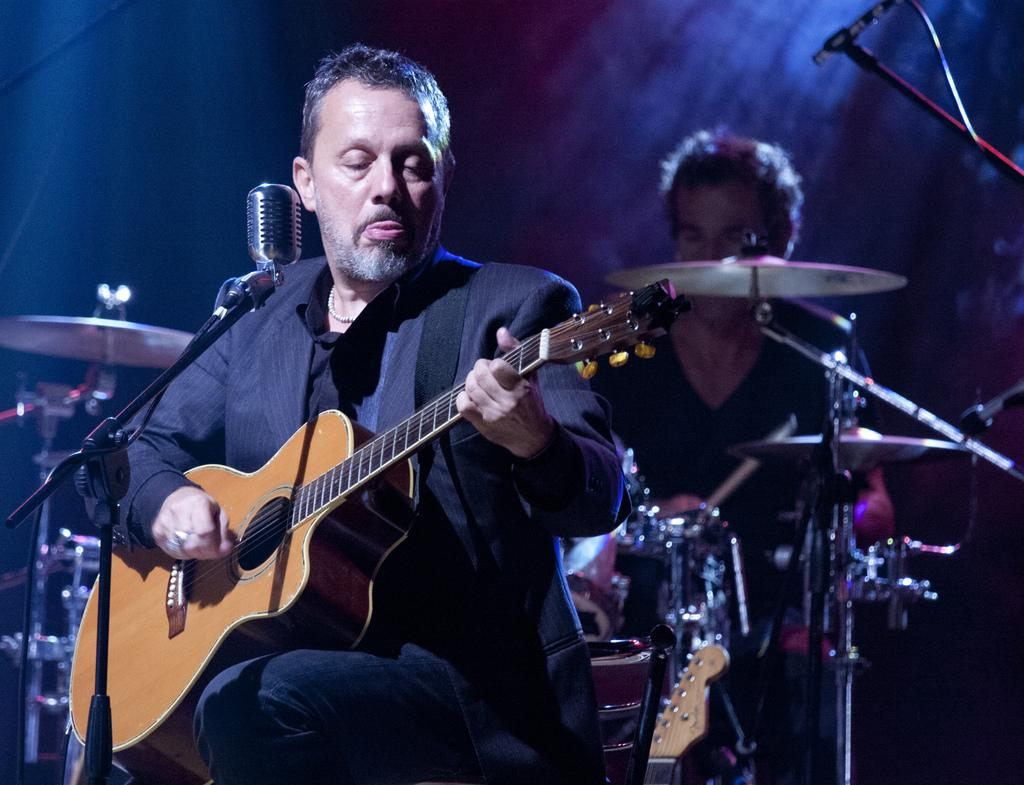What is the main activity being performed by the first man in the image? The first man is playing a guitar. What is the main activity being performed by the second man in the image? The second man is playing drums. What verse is the man playing the guitar reciting in the image? There is no indication in the image that the man playing the guitar is reciting a verse. 